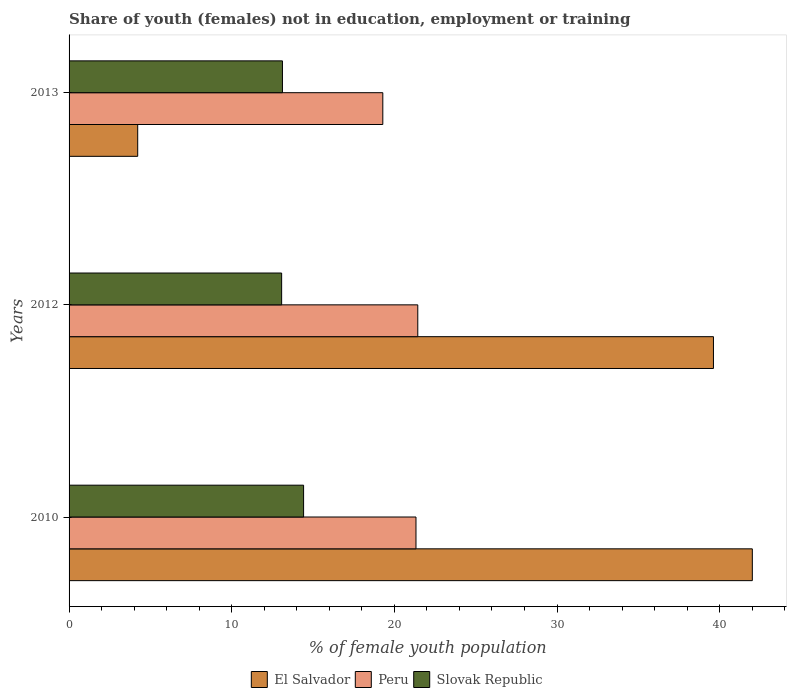How many different coloured bars are there?
Keep it short and to the point. 3. Are the number of bars on each tick of the Y-axis equal?
Keep it short and to the point. Yes. How many bars are there on the 2nd tick from the bottom?
Give a very brief answer. 3. In how many cases, is the number of bars for a given year not equal to the number of legend labels?
Your response must be concise. 0. What is the percentage of unemployed female population in in Slovak Republic in 2010?
Your response must be concise. 14.42. Across all years, what is the maximum percentage of unemployed female population in in Slovak Republic?
Provide a short and direct response. 14.42. Across all years, what is the minimum percentage of unemployed female population in in Peru?
Ensure brevity in your answer.  19.29. In which year was the percentage of unemployed female population in in Slovak Republic maximum?
Offer a very short reply. 2010. What is the total percentage of unemployed female population in in El Salvador in the graph?
Your response must be concise. 85.85. What is the difference between the percentage of unemployed female population in in El Salvador in 2010 and that in 2012?
Your response must be concise. 2.39. What is the difference between the percentage of unemployed female population in in El Salvador in 2010 and the percentage of unemployed female population in in Slovak Republic in 2012?
Make the answer very short. 28.94. What is the average percentage of unemployed female population in in Peru per year?
Provide a succinct answer. 20.69. In the year 2012, what is the difference between the percentage of unemployed female population in in Slovak Republic and percentage of unemployed female population in in Peru?
Provide a short and direct response. -8.37. What is the ratio of the percentage of unemployed female population in in Peru in 2010 to that in 2013?
Keep it short and to the point. 1.11. Is the difference between the percentage of unemployed female population in in Slovak Republic in 2010 and 2013 greater than the difference between the percentage of unemployed female population in in Peru in 2010 and 2013?
Your answer should be compact. No. What is the difference between the highest and the second highest percentage of unemployed female population in in Slovak Republic?
Offer a very short reply. 1.3. What is the difference between the highest and the lowest percentage of unemployed female population in in Slovak Republic?
Your answer should be very brief. 1.35. In how many years, is the percentage of unemployed female population in in Peru greater than the average percentage of unemployed female population in in Peru taken over all years?
Provide a short and direct response. 2. What does the 2nd bar from the top in 2010 represents?
Offer a terse response. Peru. What does the 2nd bar from the bottom in 2012 represents?
Offer a very short reply. Peru. Is it the case that in every year, the sum of the percentage of unemployed female population in in Peru and percentage of unemployed female population in in Slovak Republic is greater than the percentage of unemployed female population in in El Salvador?
Give a very brief answer. No. Are all the bars in the graph horizontal?
Keep it short and to the point. Yes. Does the graph contain grids?
Keep it short and to the point. No. What is the title of the graph?
Give a very brief answer. Share of youth (females) not in education, employment or training. What is the label or title of the X-axis?
Keep it short and to the point. % of female youth population. What is the % of female youth population in El Salvador in 2010?
Provide a succinct answer. 42.01. What is the % of female youth population in Peru in 2010?
Provide a succinct answer. 21.33. What is the % of female youth population in Slovak Republic in 2010?
Offer a terse response. 14.42. What is the % of female youth population of El Salvador in 2012?
Ensure brevity in your answer.  39.62. What is the % of female youth population in Peru in 2012?
Your answer should be very brief. 21.44. What is the % of female youth population in Slovak Republic in 2012?
Provide a short and direct response. 13.07. What is the % of female youth population in El Salvador in 2013?
Your response must be concise. 4.22. What is the % of female youth population in Peru in 2013?
Keep it short and to the point. 19.29. What is the % of female youth population of Slovak Republic in 2013?
Offer a terse response. 13.12. Across all years, what is the maximum % of female youth population of El Salvador?
Your answer should be compact. 42.01. Across all years, what is the maximum % of female youth population of Peru?
Make the answer very short. 21.44. Across all years, what is the maximum % of female youth population of Slovak Republic?
Your answer should be very brief. 14.42. Across all years, what is the minimum % of female youth population in El Salvador?
Offer a terse response. 4.22. Across all years, what is the minimum % of female youth population of Peru?
Provide a succinct answer. 19.29. Across all years, what is the minimum % of female youth population of Slovak Republic?
Provide a short and direct response. 13.07. What is the total % of female youth population in El Salvador in the graph?
Ensure brevity in your answer.  85.85. What is the total % of female youth population in Peru in the graph?
Make the answer very short. 62.06. What is the total % of female youth population of Slovak Republic in the graph?
Make the answer very short. 40.61. What is the difference between the % of female youth population of El Salvador in 2010 and that in 2012?
Provide a short and direct response. 2.39. What is the difference between the % of female youth population of Peru in 2010 and that in 2012?
Ensure brevity in your answer.  -0.11. What is the difference between the % of female youth population in Slovak Republic in 2010 and that in 2012?
Make the answer very short. 1.35. What is the difference between the % of female youth population of El Salvador in 2010 and that in 2013?
Provide a succinct answer. 37.79. What is the difference between the % of female youth population of Peru in 2010 and that in 2013?
Give a very brief answer. 2.04. What is the difference between the % of female youth population of El Salvador in 2012 and that in 2013?
Provide a succinct answer. 35.4. What is the difference between the % of female youth population in Peru in 2012 and that in 2013?
Your answer should be very brief. 2.15. What is the difference between the % of female youth population in Slovak Republic in 2012 and that in 2013?
Your answer should be compact. -0.05. What is the difference between the % of female youth population of El Salvador in 2010 and the % of female youth population of Peru in 2012?
Provide a succinct answer. 20.57. What is the difference between the % of female youth population in El Salvador in 2010 and the % of female youth population in Slovak Republic in 2012?
Provide a short and direct response. 28.94. What is the difference between the % of female youth population of Peru in 2010 and the % of female youth population of Slovak Republic in 2012?
Give a very brief answer. 8.26. What is the difference between the % of female youth population in El Salvador in 2010 and the % of female youth population in Peru in 2013?
Ensure brevity in your answer.  22.72. What is the difference between the % of female youth population in El Salvador in 2010 and the % of female youth population in Slovak Republic in 2013?
Keep it short and to the point. 28.89. What is the difference between the % of female youth population of Peru in 2010 and the % of female youth population of Slovak Republic in 2013?
Your answer should be compact. 8.21. What is the difference between the % of female youth population of El Salvador in 2012 and the % of female youth population of Peru in 2013?
Your answer should be very brief. 20.33. What is the difference between the % of female youth population of Peru in 2012 and the % of female youth population of Slovak Republic in 2013?
Ensure brevity in your answer.  8.32. What is the average % of female youth population of El Salvador per year?
Provide a short and direct response. 28.62. What is the average % of female youth population of Peru per year?
Make the answer very short. 20.69. What is the average % of female youth population in Slovak Republic per year?
Make the answer very short. 13.54. In the year 2010, what is the difference between the % of female youth population in El Salvador and % of female youth population in Peru?
Offer a terse response. 20.68. In the year 2010, what is the difference between the % of female youth population of El Salvador and % of female youth population of Slovak Republic?
Give a very brief answer. 27.59. In the year 2010, what is the difference between the % of female youth population in Peru and % of female youth population in Slovak Republic?
Your answer should be very brief. 6.91. In the year 2012, what is the difference between the % of female youth population in El Salvador and % of female youth population in Peru?
Make the answer very short. 18.18. In the year 2012, what is the difference between the % of female youth population of El Salvador and % of female youth population of Slovak Republic?
Keep it short and to the point. 26.55. In the year 2012, what is the difference between the % of female youth population of Peru and % of female youth population of Slovak Republic?
Make the answer very short. 8.37. In the year 2013, what is the difference between the % of female youth population of El Salvador and % of female youth population of Peru?
Keep it short and to the point. -15.07. In the year 2013, what is the difference between the % of female youth population of El Salvador and % of female youth population of Slovak Republic?
Your response must be concise. -8.9. In the year 2013, what is the difference between the % of female youth population in Peru and % of female youth population in Slovak Republic?
Make the answer very short. 6.17. What is the ratio of the % of female youth population in El Salvador in 2010 to that in 2012?
Your answer should be very brief. 1.06. What is the ratio of the % of female youth population of Peru in 2010 to that in 2012?
Offer a very short reply. 0.99. What is the ratio of the % of female youth population in Slovak Republic in 2010 to that in 2012?
Offer a very short reply. 1.1. What is the ratio of the % of female youth population in El Salvador in 2010 to that in 2013?
Provide a short and direct response. 9.96. What is the ratio of the % of female youth population of Peru in 2010 to that in 2013?
Provide a short and direct response. 1.11. What is the ratio of the % of female youth population of Slovak Republic in 2010 to that in 2013?
Make the answer very short. 1.1. What is the ratio of the % of female youth population in El Salvador in 2012 to that in 2013?
Your answer should be compact. 9.39. What is the ratio of the % of female youth population of Peru in 2012 to that in 2013?
Ensure brevity in your answer.  1.11. What is the ratio of the % of female youth population in Slovak Republic in 2012 to that in 2013?
Give a very brief answer. 1. What is the difference between the highest and the second highest % of female youth population in El Salvador?
Your answer should be compact. 2.39. What is the difference between the highest and the second highest % of female youth population in Peru?
Keep it short and to the point. 0.11. What is the difference between the highest and the lowest % of female youth population of El Salvador?
Provide a succinct answer. 37.79. What is the difference between the highest and the lowest % of female youth population in Peru?
Your answer should be very brief. 2.15. What is the difference between the highest and the lowest % of female youth population in Slovak Republic?
Offer a terse response. 1.35. 